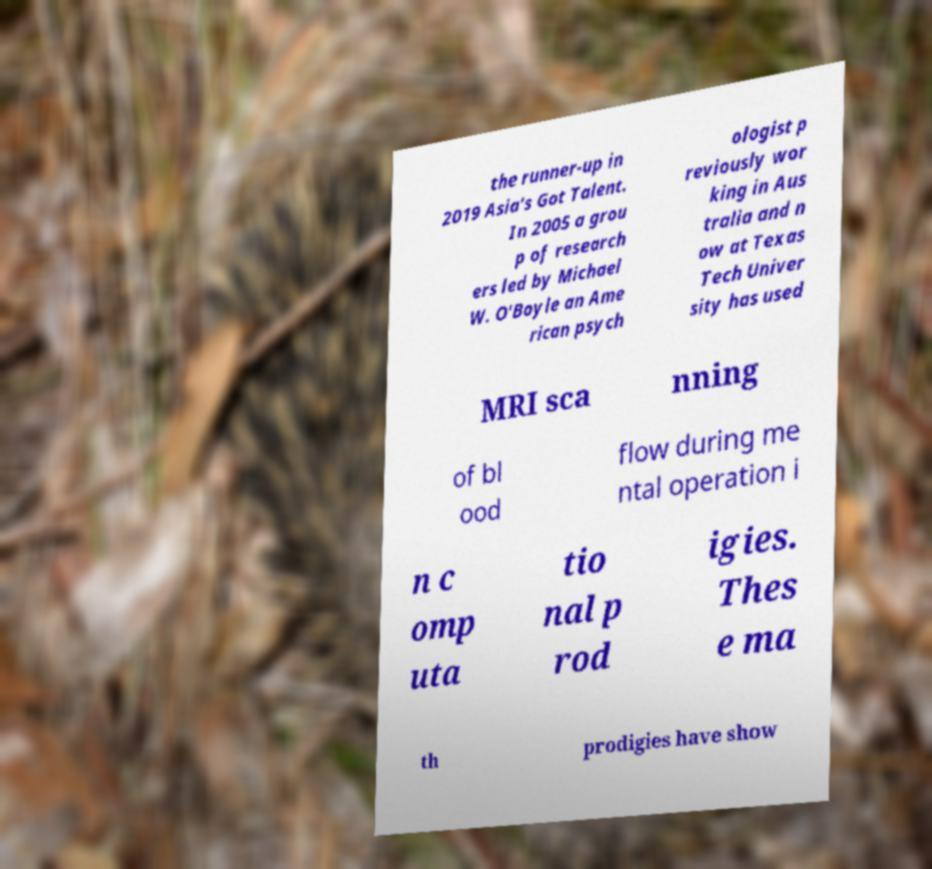Can you read and provide the text displayed in the image?This photo seems to have some interesting text. Can you extract and type it out for me? the runner-up in 2019 Asia's Got Talent. In 2005 a grou p of research ers led by Michael W. O'Boyle an Ame rican psych ologist p reviously wor king in Aus tralia and n ow at Texas Tech Univer sity has used MRI sca nning of bl ood flow during me ntal operation i n c omp uta tio nal p rod igies. Thes e ma th prodigies have show 